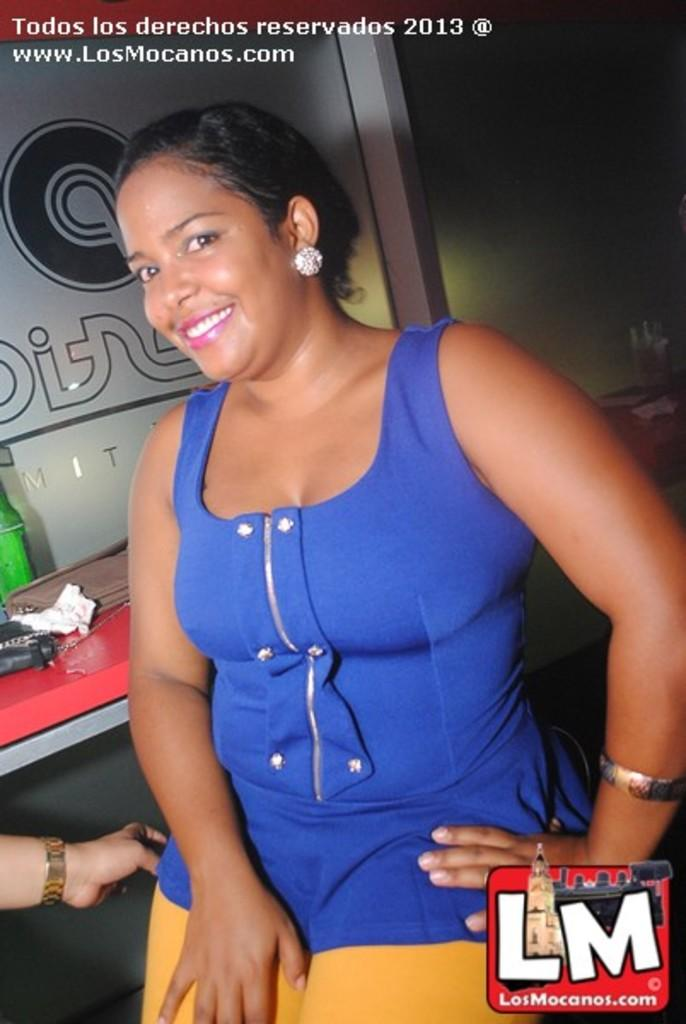<image>
Write a terse but informative summary of the picture. A woman in blue, there are the letters LM to the bottom right. 